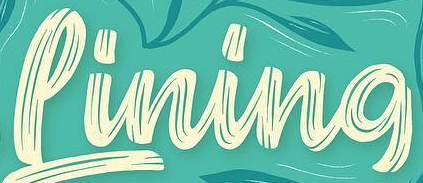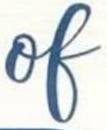What text is displayed in these images sequentially, separated by a semicolon? Pining; of 